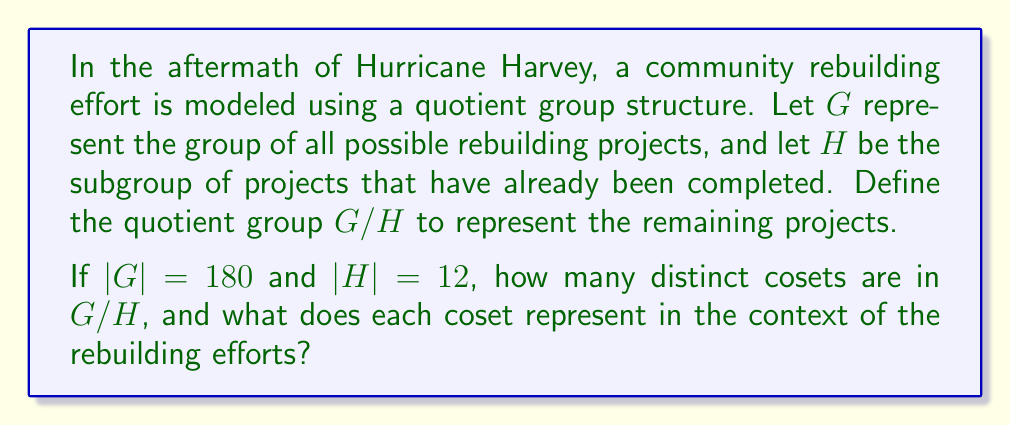Provide a solution to this math problem. To solve this problem, we need to understand the concept of quotient groups and apply it to the given scenario:

1) In group theory, if $G$ is a group and $H$ is a subgroup of $G$, then the quotient group $G/H$ is the set of all cosets of $H$ in $G$.

2) The number of distinct cosets in $G/H$ is equal to the index of $H$ in $G$, denoted as $[G:H]$.

3) The index $[G:H]$ is calculated by dividing the order of $G$ by the order of $H$:

   $$[G:H] = \frac{|G|}{|H|}$$

4) In this case, $|G| = 180$ and $|H| = 12$, so:

   $$[G:H] = \frac{180}{12} = 15$$

5) Therefore, there are 15 distinct cosets in $G/H$.

6) In the context of rebuilding efforts:
   - $G$ represents all possible rebuilding projects.
   - $H$ represents the projects that have been completed.
   - Each coset in $G/H$ represents a set of projects that are equivalent in terms of their completion status.
   - The 15 cosets effectively categorize the remaining projects into 15 distinct groups or phases of completion.

This structure allows community leaders and reporters to track the progress of rebuilding efforts by monitoring the transition of projects from one coset to another as they move towards completion.
Answer: There are 15 distinct cosets in $G/H$. Each coset represents a set of rebuilding projects that are equivalent in terms of their completion status, effectively categorizing the remaining projects into 15 distinct groups or phases of completion. 